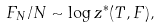Convert formula to latex. <formula><loc_0><loc_0><loc_500><loc_500>F _ { N } / N \sim \log z ^ { * } ( T , F ) ,</formula> 